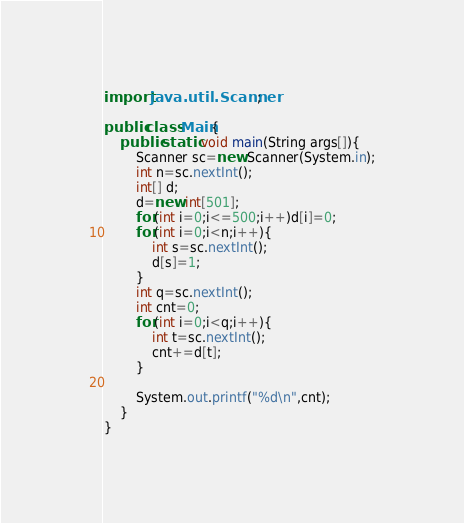<code> <loc_0><loc_0><loc_500><loc_500><_Java_>import java.util.Scanner;

public class Main{
	public static void main(String args[]){
		Scanner sc=new Scanner(System.in);
		int n=sc.nextInt();
		int[] d;
		d=new int[501];
		for(int i=0;i<=500;i++)d[i]=0;
		for(int i=0;i<n;i++){
			int s=sc.nextInt();
			d[s]=1;
		}
		int q=sc.nextInt();
		int cnt=0;
		for(int i=0;i<q;i++){
			int t=sc.nextInt();
			cnt+=d[t];
		}

		System.out.printf("%d\n",cnt);
	}
}</code> 